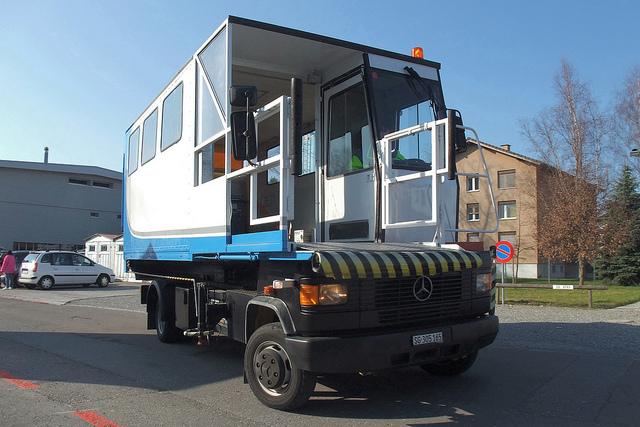What is on the side of the truck?
Keep it brief. Windows. How many people are visible behind the car?
Be succinct. 1. What is being towed by the pickup?
Quick response, please. Nothing. What color is the truck?
Be succinct. White and blue. What is the shape of the street corner?
Concise answer only. Square. IS this photo taken in America?
Quick response, please. No. How many cylinders does this truck likely have?
Write a very short answer. 6. What colors are the stripes in the middle of the street?
Answer briefly. Red. How many people are in the photo?
Write a very short answer. 0. Is the truck empty?
Answer briefly. Yes. Why is the front of the vehicle decorated with black and yellow stripes?
Quick response, please. Caution. Is the truck parked on the road?
Be succinct. Yes. Does the street need to be resurfaced?
Quick response, please. No. What colors are on the top portion of this vehicle?
Be succinct. White. 